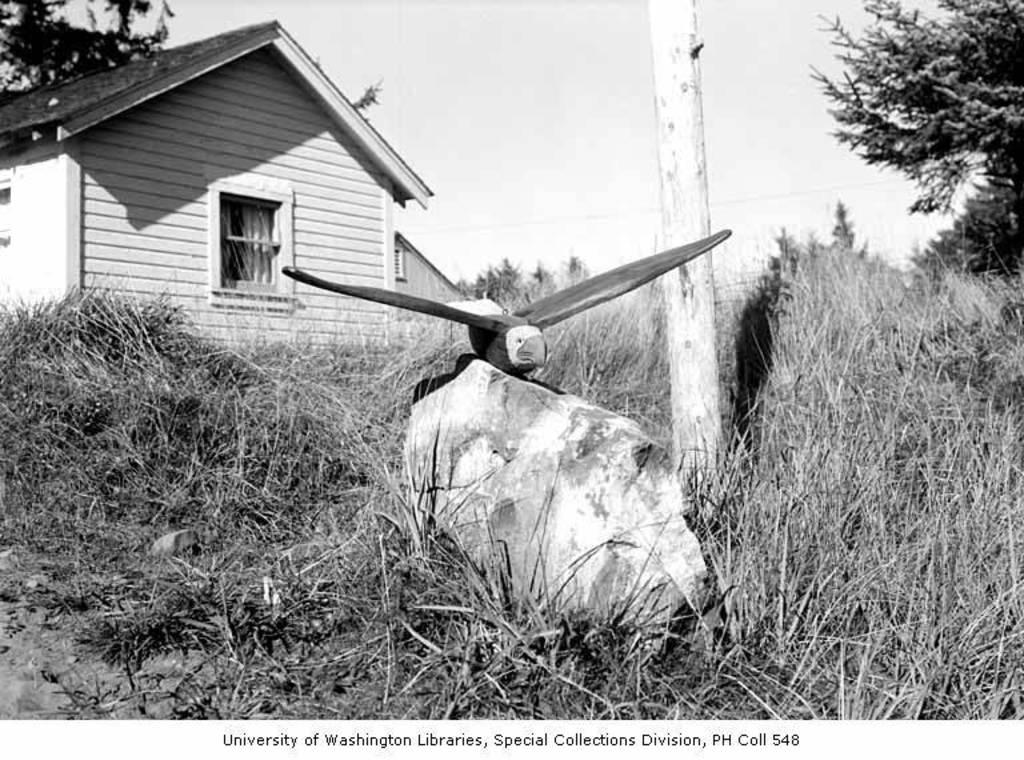What is the color scheme of the image? The image is black and white. What type of structure can be seen in the image? There is a house in the image. What type of vegetation is present in the image? There are plants and trees in the image. What is the object on the rock in the image? The facts do not specify what the object on the rock is. What is visible in the background of the image? The sky is visible in the background of the image. What scientific experiment is being conducted in the image? There is no indication of a scientific experiment being conducted in the image. What type of rock is the object on in the image? The facts do not specify the type of rock the object is on. 